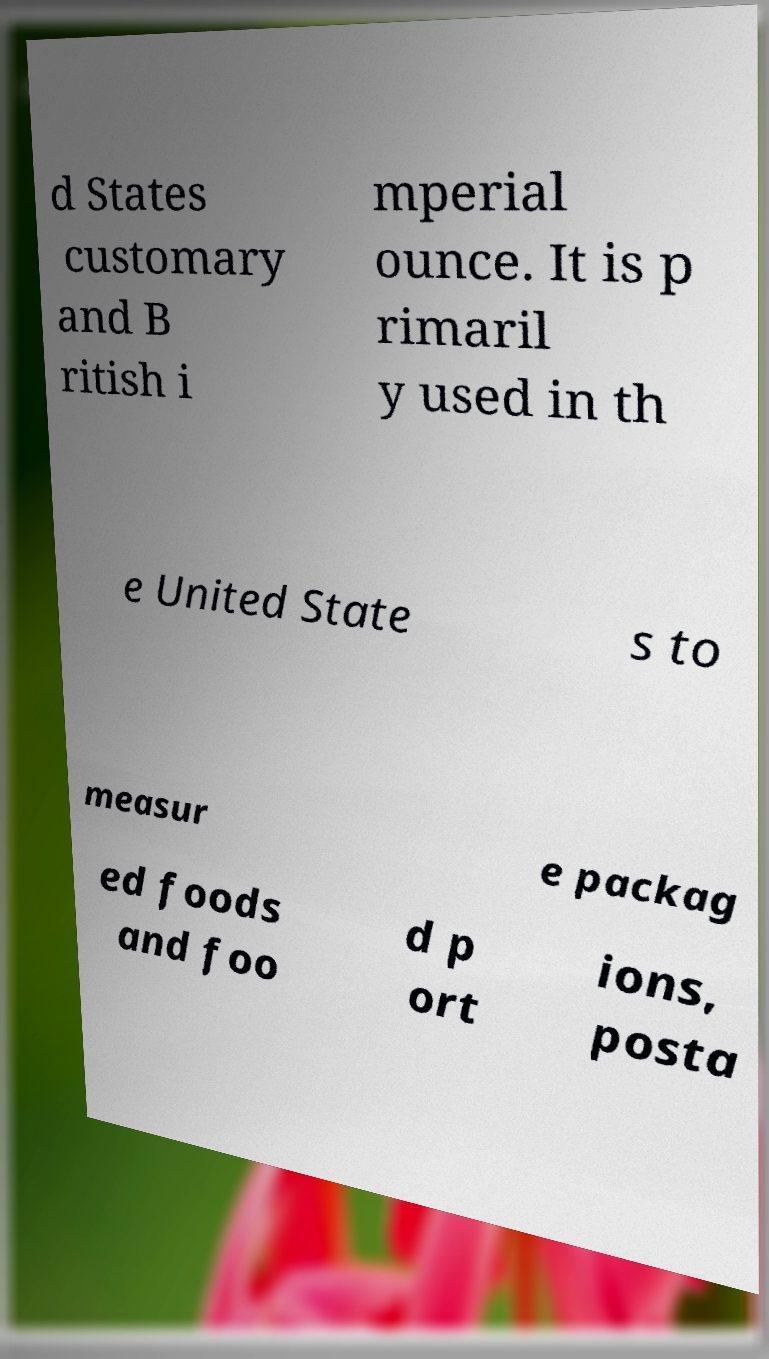Please read and relay the text visible in this image. What does it say? d States customary and B ritish i mperial ounce. It is p rimaril y used in th e United State s to measur e packag ed foods and foo d p ort ions, posta 